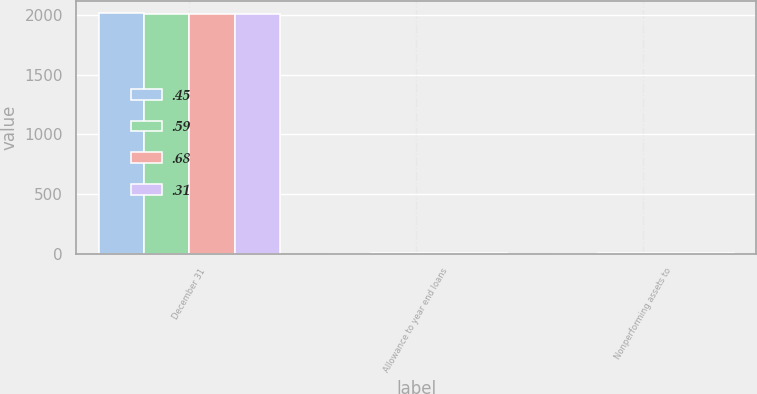Convert chart. <chart><loc_0><loc_0><loc_500><loc_500><stacked_bar_chart><ecel><fcel>December 31<fcel>Allowance to year end loans<fcel>Nonperforming assets to<nl><fcel>0.45<fcel>2014<fcel>0.31<fcel>0.31<nl><fcel>0.59<fcel>2013<fcel>0.39<fcel>0.45<nl><fcel>0.68<fcel>2012<fcel>0.52<fcel>0.54<nl><fcel>0.31<fcel>2011<fcel>0.55<fcel>0.59<nl></chart> 